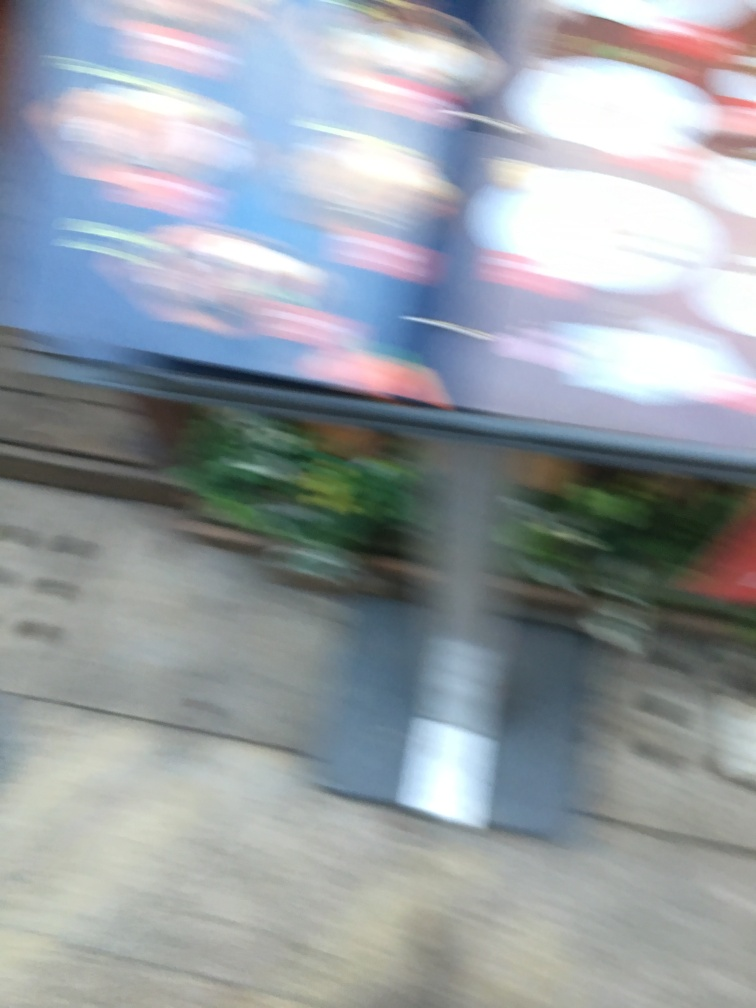Are there any quality issues with this image? The image is blurred and does not have a clear focus, making it difficult to discern fine details. This compromises its quality for most uses such as accurate identification or detailed analysis. 